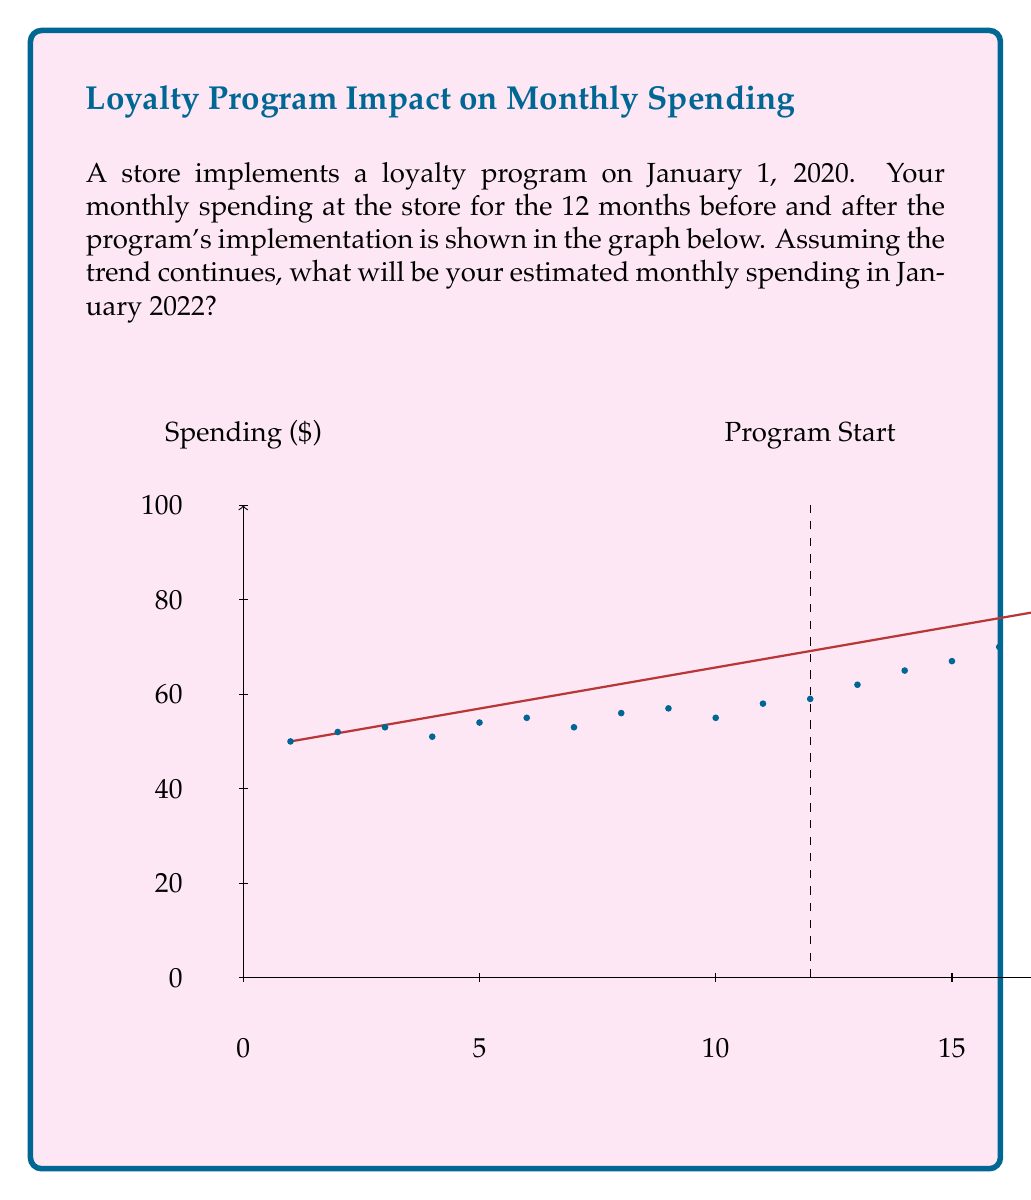Can you answer this question? To solve this problem, we'll use linear regression to analyze the trend in spending habits:

1) First, we need to calculate the slope of the trend line. We can use the points at the start and end of the data:
   $m = \frac{y_2 - y_1}{x_2 - x_1} = \frac{90 - 50}{24 - 1} = \frac{40}{23} \approx 1.74$

2) The y-intercept (b) can be calculated using the point-slope form:
   $50 = 1.74(1) + b$
   $b = 50 - 1.74 = 48.26$

3) Our linear equation is thus:
   $y = 1.74x + 48.26$

4) January 2022 would be 24 months after the program start, or 36 months from the beginning of our data.

5) Plugging 36 into our equation:
   $y = 1.74(36) + 48.26 = 110.90$

Therefore, the estimated monthly spending in January 2022 would be $110.90.

This analysis shows a clear upward trend in spending after the loyalty program's implementation, suggesting a positive long-term impact on customer spending habits.
Answer: $110.90 